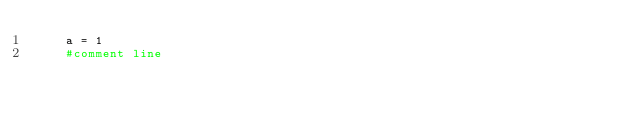<code> <loc_0><loc_0><loc_500><loc_500><_Python_>    a = 1
    #comment line
</code> 